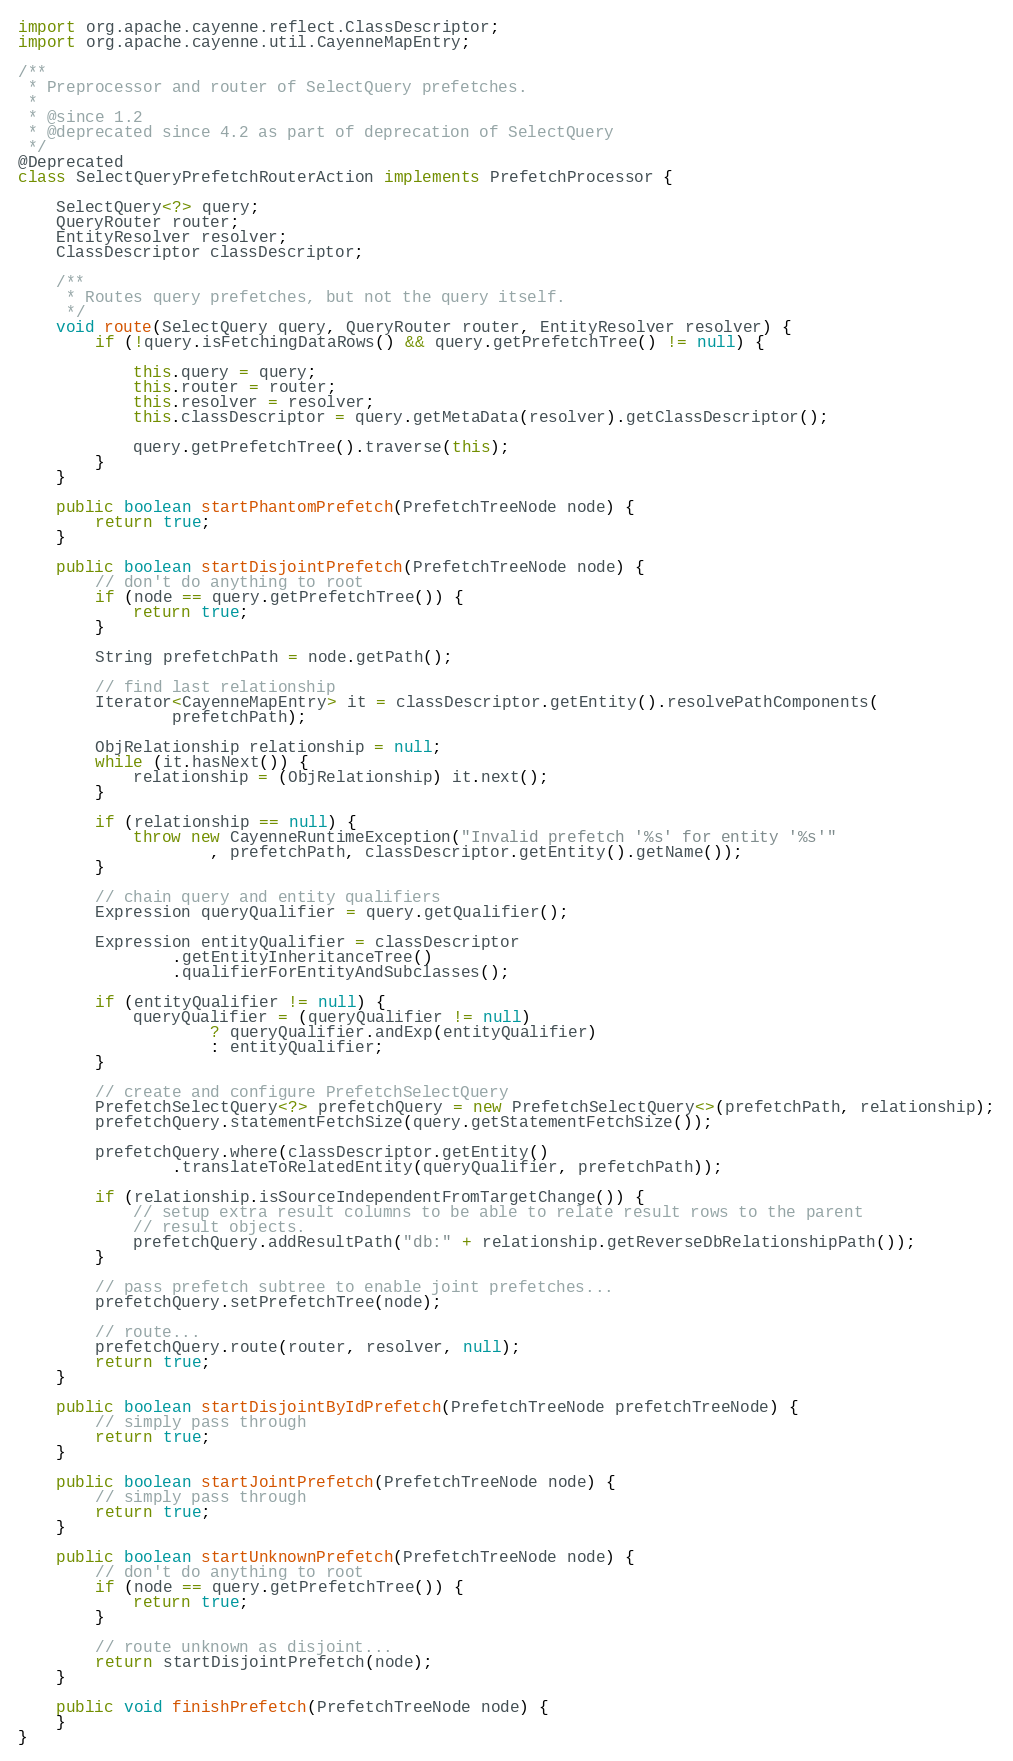Convert code to text. <code><loc_0><loc_0><loc_500><loc_500><_Java_>import org.apache.cayenne.reflect.ClassDescriptor;
import org.apache.cayenne.util.CayenneMapEntry;

/**
 * Preprocessor and router of SelectQuery prefetches.
 * 
 * @since 1.2
 * @deprecated since 4.2 as part of deprecation of SelectQuery
 */
@Deprecated
class SelectQueryPrefetchRouterAction implements PrefetchProcessor {

    SelectQuery<?> query;
    QueryRouter router;
    EntityResolver resolver;
    ClassDescriptor classDescriptor;

    /**
     * Routes query prefetches, but not the query itself.
     */
    void route(SelectQuery query, QueryRouter router, EntityResolver resolver) {
        if (!query.isFetchingDataRows() && query.getPrefetchTree() != null) {

            this.query = query;
            this.router = router;
            this.resolver = resolver;
            this.classDescriptor = query.getMetaData(resolver).getClassDescriptor();

            query.getPrefetchTree().traverse(this);
        }
    }

    public boolean startPhantomPrefetch(PrefetchTreeNode node) {
        return true;
    }

    public boolean startDisjointPrefetch(PrefetchTreeNode node) {
        // don't do anything to root
        if (node == query.getPrefetchTree()) {
            return true;
        }

        String prefetchPath = node.getPath();

        // find last relationship
        Iterator<CayenneMapEntry> it = classDescriptor.getEntity().resolvePathComponents(
                prefetchPath);

        ObjRelationship relationship = null;
        while (it.hasNext()) {
            relationship = (ObjRelationship) it.next();
        }

        if (relationship == null) {
            throw new CayenneRuntimeException("Invalid prefetch '%s' for entity '%s'"
                    , prefetchPath, classDescriptor.getEntity().getName());
        }

        // chain query and entity qualifiers
        Expression queryQualifier = query.getQualifier();

        Expression entityQualifier = classDescriptor
                .getEntityInheritanceTree()
                .qualifierForEntityAndSubclasses();

        if (entityQualifier != null) {
            queryQualifier = (queryQualifier != null)
                    ? queryQualifier.andExp(entityQualifier)
                    : entityQualifier;
        }

        // create and configure PrefetchSelectQuery
        PrefetchSelectQuery<?> prefetchQuery = new PrefetchSelectQuery<>(prefetchPath, relationship);
        prefetchQuery.statementFetchSize(query.getStatementFetchSize());

        prefetchQuery.where(classDescriptor.getEntity()
                .translateToRelatedEntity(queryQualifier, prefetchPath));

        if (relationship.isSourceIndependentFromTargetChange()) {
            // setup extra result columns to be able to relate result rows to the parent
            // result objects.
            prefetchQuery.addResultPath("db:" + relationship.getReverseDbRelationshipPath());
        }

        // pass prefetch subtree to enable joint prefetches...
        prefetchQuery.setPrefetchTree(node);

        // route...
        prefetchQuery.route(router, resolver, null);
        return true;
    }

    public boolean startDisjointByIdPrefetch(PrefetchTreeNode prefetchTreeNode) {
        // simply pass through
        return true;
    }

    public boolean startJointPrefetch(PrefetchTreeNode node) {
        // simply pass through
        return true;
    }

    public boolean startUnknownPrefetch(PrefetchTreeNode node) {
        // don't do anything to root
        if (node == query.getPrefetchTree()) {
            return true;
        }

        // route unknown as disjoint...
        return startDisjointPrefetch(node);
    }

    public void finishPrefetch(PrefetchTreeNode node) {
    }
}
</code> 